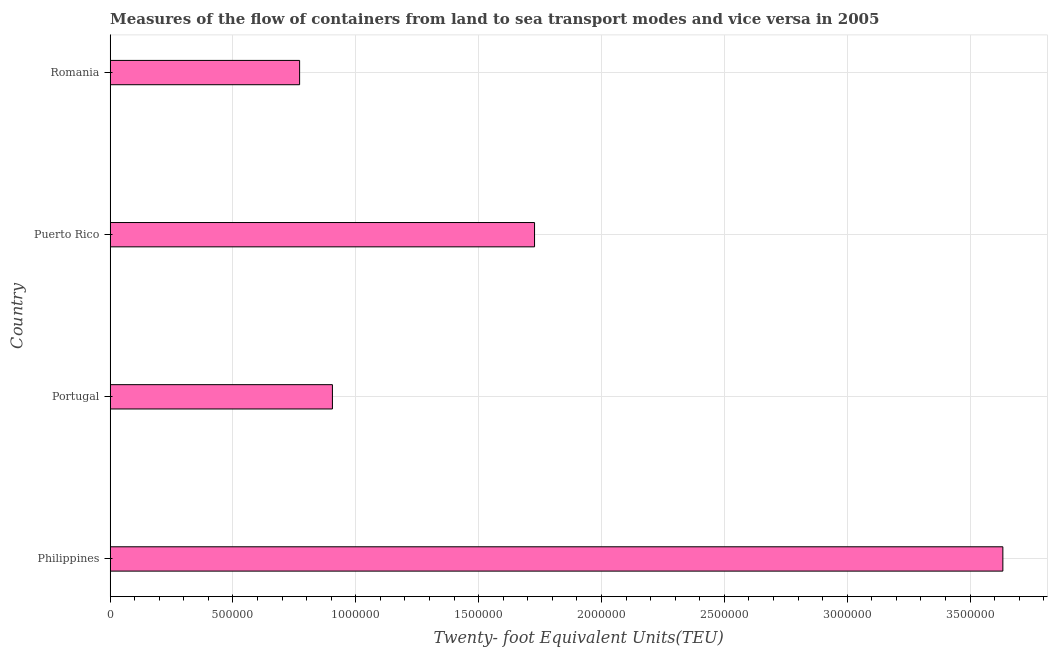Does the graph contain any zero values?
Make the answer very short. No. Does the graph contain grids?
Ensure brevity in your answer.  Yes. What is the title of the graph?
Give a very brief answer. Measures of the flow of containers from land to sea transport modes and vice versa in 2005. What is the label or title of the X-axis?
Make the answer very short. Twenty- foot Equivalent Units(TEU). What is the label or title of the Y-axis?
Provide a short and direct response. Country. What is the container port traffic in Puerto Rico?
Give a very brief answer. 1.73e+06. Across all countries, what is the maximum container port traffic?
Ensure brevity in your answer.  3.63e+06. Across all countries, what is the minimum container port traffic?
Make the answer very short. 7.71e+05. In which country was the container port traffic maximum?
Your answer should be compact. Philippines. In which country was the container port traffic minimum?
Your response must be concise. Romania. What is the sum of the container port traffic?
Your answer should be compact. 7.04e+06. What is the difference between the container port traffic in Portugal and Romania?
Keep it short and to the point. 1.34e+05. What is the average container port traffic per country?
Keep it short and to the point. 1.76e+06. What is the median container port traffic?
Offer a very short reply. 1.32e+06. What is the ratio of the container port traffic in Puerto Rico to that in Romania?
Your answer should be compact. 2.24. Is the difference between the container port traffic in Portugal and Romania greater than the difference between any two countries?
Provide a short and direct response. No. What is the difference between the highest and the second highest container port traffic?
Provide a succinct answer. 1.91e+06. Is the sum of the container port traffic in Philippines and Portugal greater than the maximum container port traffic across all countries?
Your response must be concise. Yes. What is the difference between the highest and the lowest container port traffic?
Keep it short and to the point. 2.86e+06. Are all the bars in the graph horizontal?
Your answer should be very brief. Yes. What is the difference between two consecutive major ticks on the X-axis?
Offer a terse response. 5.00e+05. Are the values on the major ticks of X-axis written in scientific E-notation?
Your response must be concise. No. What is the Twenty- foot Equivalent Units(TEU) in Philippines?
Your answer should be very brief. 3.63e+06. What is the Twenty- foot Equivalent Units(TEU) of Portugal?
Ensure brevity in your answer.  9.05e+05. What is the Twenty- foot Equivalent Units(TEU) of Puerto Rico?
Make the answer very short. 1.73e+06. What is the Twenty- foot Equivalent Units(TEU) in Romania?
Keep it short and to the point. 7.71e+05. What is the difference between the Twenty- foot Equivalent Units(TEU) in Philippines and Portugal?
Provide a succinct answer. 2.73e+06. What is the difference between the Twenty- foot Equivalent Units(TEU) in Philippines and Puerto Rico?
Your answer should be very brief. 1.91e+06. What is the difference between the Twenty- foot Equivalent Units(TEU) in Philippines and Romania?
Your answer should be compact. 2.86e+06. What is the difference between the Twenty- foot Equivalent Units(TEU) in Portugal and Puerto Rico?
Offer a very short reply. -8.23e+05. What is the difference between the Twenty- foot Equivalent Units(TEU) in Portugal and Romania?
Give a very brief answer. 1.34e+05. What is the difference between the Twenty- foot Equivalent Units(TEU) in Puerto Rico and Romania?
Your answer should be very brief. 9.56e+05. What is the ratio of the Twenty- foot Equivalent Units(TEU) in Philippines to that in Portugal?
Provide a short and direct response. 4.02. What is the ratio of the Twenty- foot Equivalent Units(TEU) in Philippines to that in Puerto Rico?
Make the answer very short. 2.1. What is the ratio of the Twenty- foot Equivalent Units(TEU) in Philippines to that in Romania?
Make the answer very short. 4.71. What is the ratio of the Twenty- foot Equivalent Units(TEU) in Portugal to that in Puerto Rico?
Make the answer very short. 0.52. What is the ratio of the Twenty- foot Equivalent Units(TEU) in Portugal to that in Romania?
Give a very brief answer. 1.17. What is the ratio of the Twenty- foot Equivalent Units(TEU) in Puerto Rico to that in Romania?
Your answer should be compact. 2.24. 